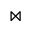<formula> <loc_0><loc_0><loc_500><loc_500>\bowtie</formula> 